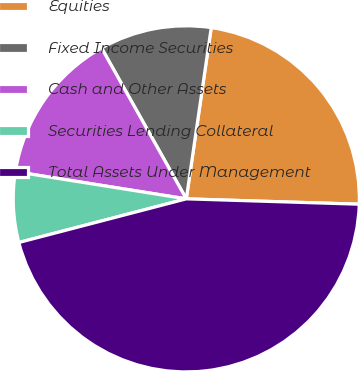Convert chart. <chart><loc_0><loc_0><loc_500><loc_500><pie_chart><fcel>Equities<fcel>Fixed Income Securities<fcel>Cash and Other Assets<fcel>Securities Lending Collateral<fcel>Total Assets Under Management<nl><fcel>23.19%<fcel>10.45%<fcel>14.34%<fcel>6.57%<fcel>45.45%<nl></chart> 